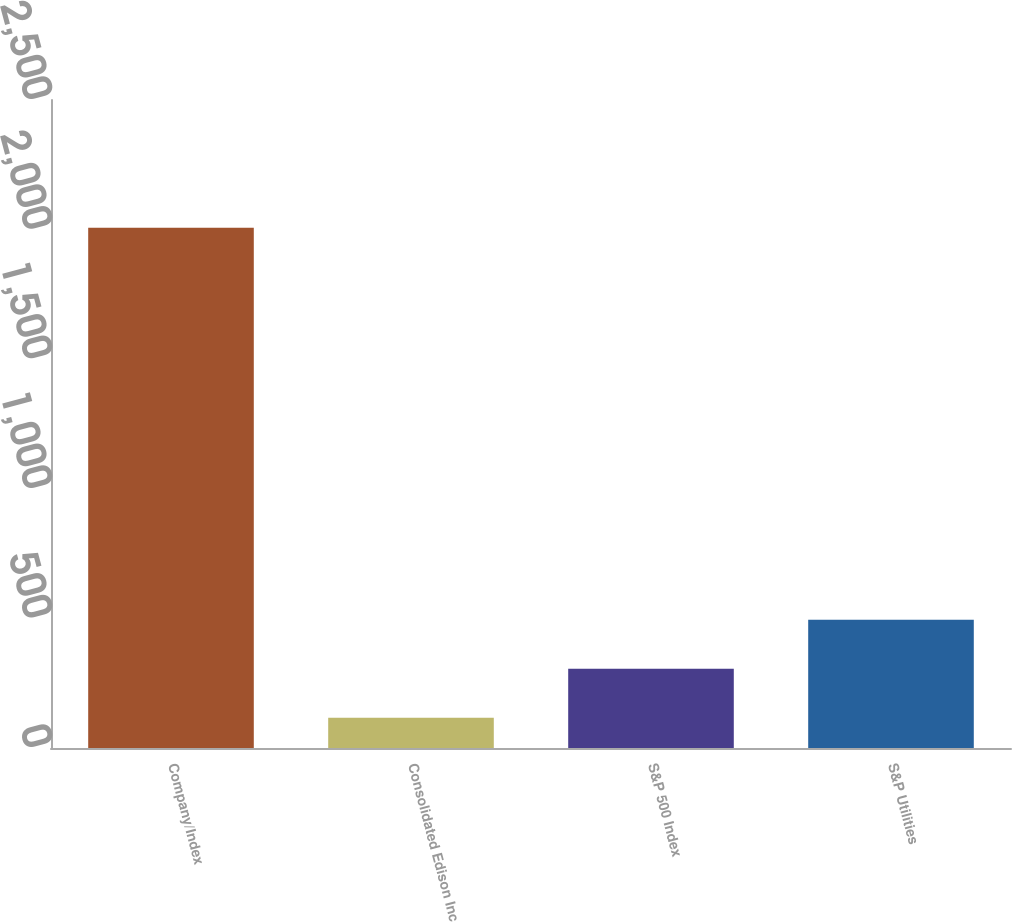Convert chart. <chart><loc_0><loc_0><loc_500><loc_500><bar_chart><fcel>Company/Index<fcel>Consolidated Edison Inc<fcel>S&P 500 Index<fcel>S&P Utilities<nl><fcel>2007<fcel>116.4<fcel>305.46<fcel>494.52<nl></chart> 